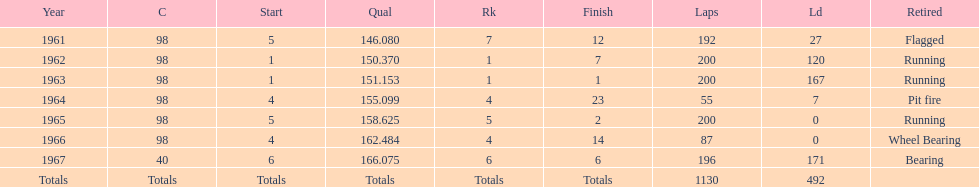What car achieved the highest qual? 40. 